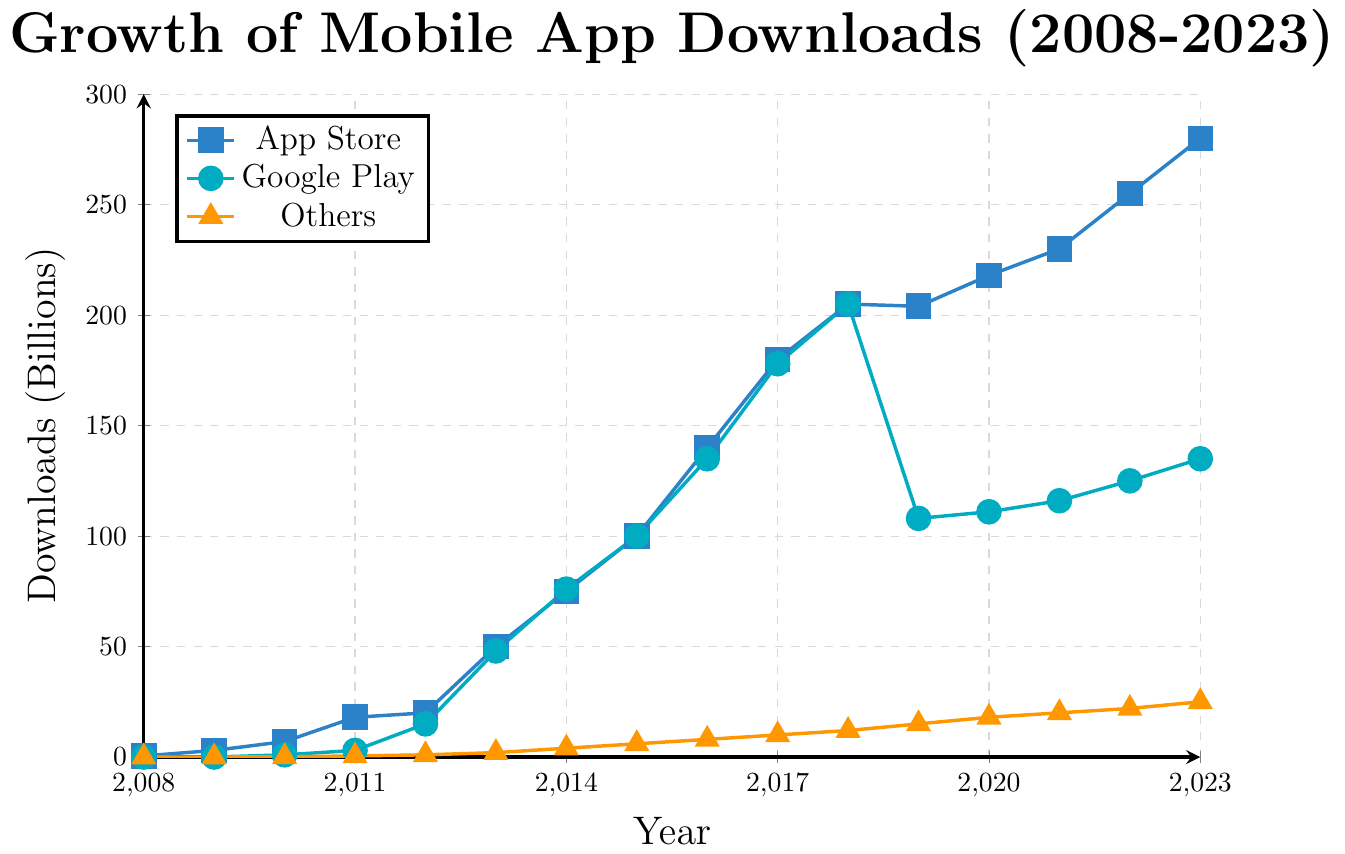What's the total number of app downloads (in billions) from all app stores in 2023? Sum up the downloads from App Store (280 billion), Google Play (135 billion), and Others (25 billion). Total downloads = 280 + 135 + 25 = 440 billion
Answer: 440 billion When did Google Play downloads first surpass 100 billion? Check the year where Google Play first exceeded 100 billion. Google Play downloads first surpassed 100 billion in 2015, reaching 100 billion
Answer: 2015 Which app store had the highest number of downloads in 2017 and by how much did it differ from the second highest? Compare the downloads for each app store in 2017. App Store had 180 billion, Google Play had 178 billion, and Others had 10 billion. The highest was App Store with 180 billion, differing by 180 - 178 = 2 billion from Google Play
Answer: App Store, 2 billion How did the downloads on Google Play between 2018 and 2019 change, and what is the percentage change? The downloads in 2018 (205 billion) and 2019 (108 billion) show a decrease. The change is 205 - 108 = 97 billion. Percentage change = (97/205) * 100 ≈ 47.32%
Answer: Decreased by 97 billion, ≈ 47.32% In which year did the "Others" category reach 10 billion downloads? Identify the year when the Others category first reached 10 billion. This was achieved in 2017
Answer: 2017 What was the average number of App Store downloads from 2008 to 2023? Sum up the App Store downloads from 2008 to 2023 and divide by the number of years. Sum = 0.5 + 3 + 7 + 18 + 20 + 50 + 75 + 100 + 140 + 180 + 205 + 204 + 218 + 230 + 255 + 280 = 1985.5 billion. Average = 1985.5 / 16 ≈ 124.09 billion
Answer: ≈ 124.09 billion Between 2020 and 2023, which app store showed the highest growth in downloads (in billions)? Calculate the change in downloads for each store between 2020 and 2023: 
App Store: 280 - 218 = 62 billion,
Google Play: 135 - 111 = 24 billion,
Others: 25 - 18 = 7 billion. 
The highest growth is for App Store, 62 billion
Answer: App Store, 62 billion By how much did the downloads in the 'Others' category increase from 2010 to 2023? Calculate the difference in downloads from 2010 (0.1 billion) to 2023 (25 billion). Difference = 25 - 0.1 = 24.9 billion
Answer: 24.9 billion Which year had the closest number of downloads from App Store and Google Play, and what were the numbers? Compare the downloads for both stores across all years. In 2018, both had 205 billion downloads
Answer: 2018, 205 billion each 